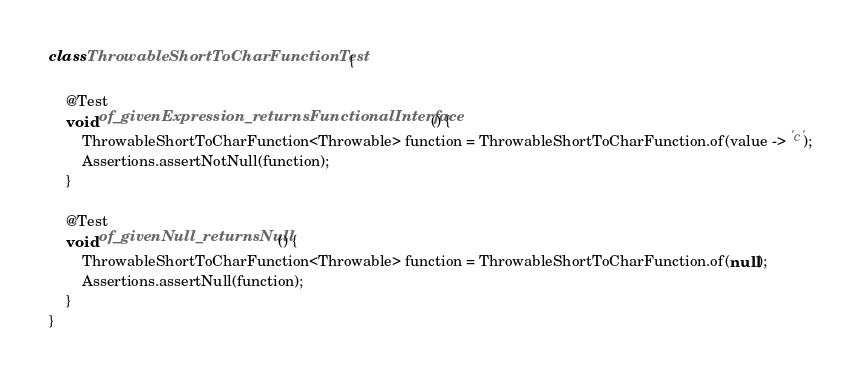Convert code to text. <code><loc_0><loc_0><loc_500><loc_500><_Java_>
class ThrowableShortToCharFunctionTest {

    @Test
    void of_givenExpression_returnsFunctionalInterface() {
        ThrowableShortToCharFunction<Throwable> function = ThrowableShortToCharFunction.of(value -> 'c');
        Assertions.assertNotNull(function);
    }

    @Test
    void of_givenNull_returnsNull() {
        ThrowableShortToCharFunction<Throwable> function = ThrowableShortToCharFunction.of(null);
        Assertions.assertNull(function);
    }
}
</code> 